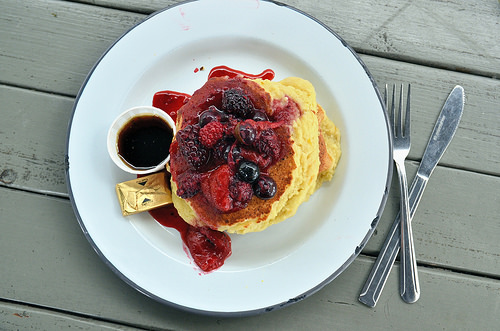<image>
Is the fork on the plate? No. The fork is not positioned on the plate. They may be near each other, but the fork is not supported by or resting on top of the plate. 